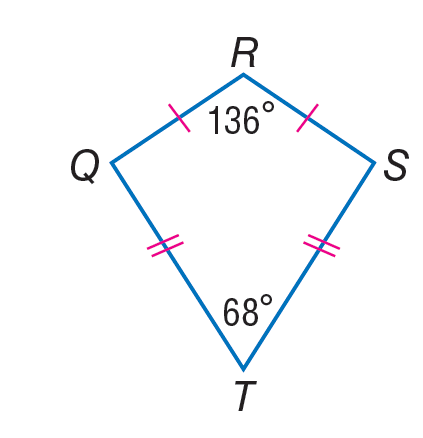Question: If Q R S T is a kite, find m \angle R S T.
Choices:
A. 39
B. 68
C. 78
D. 136
Answer with the letter. Answer: C 